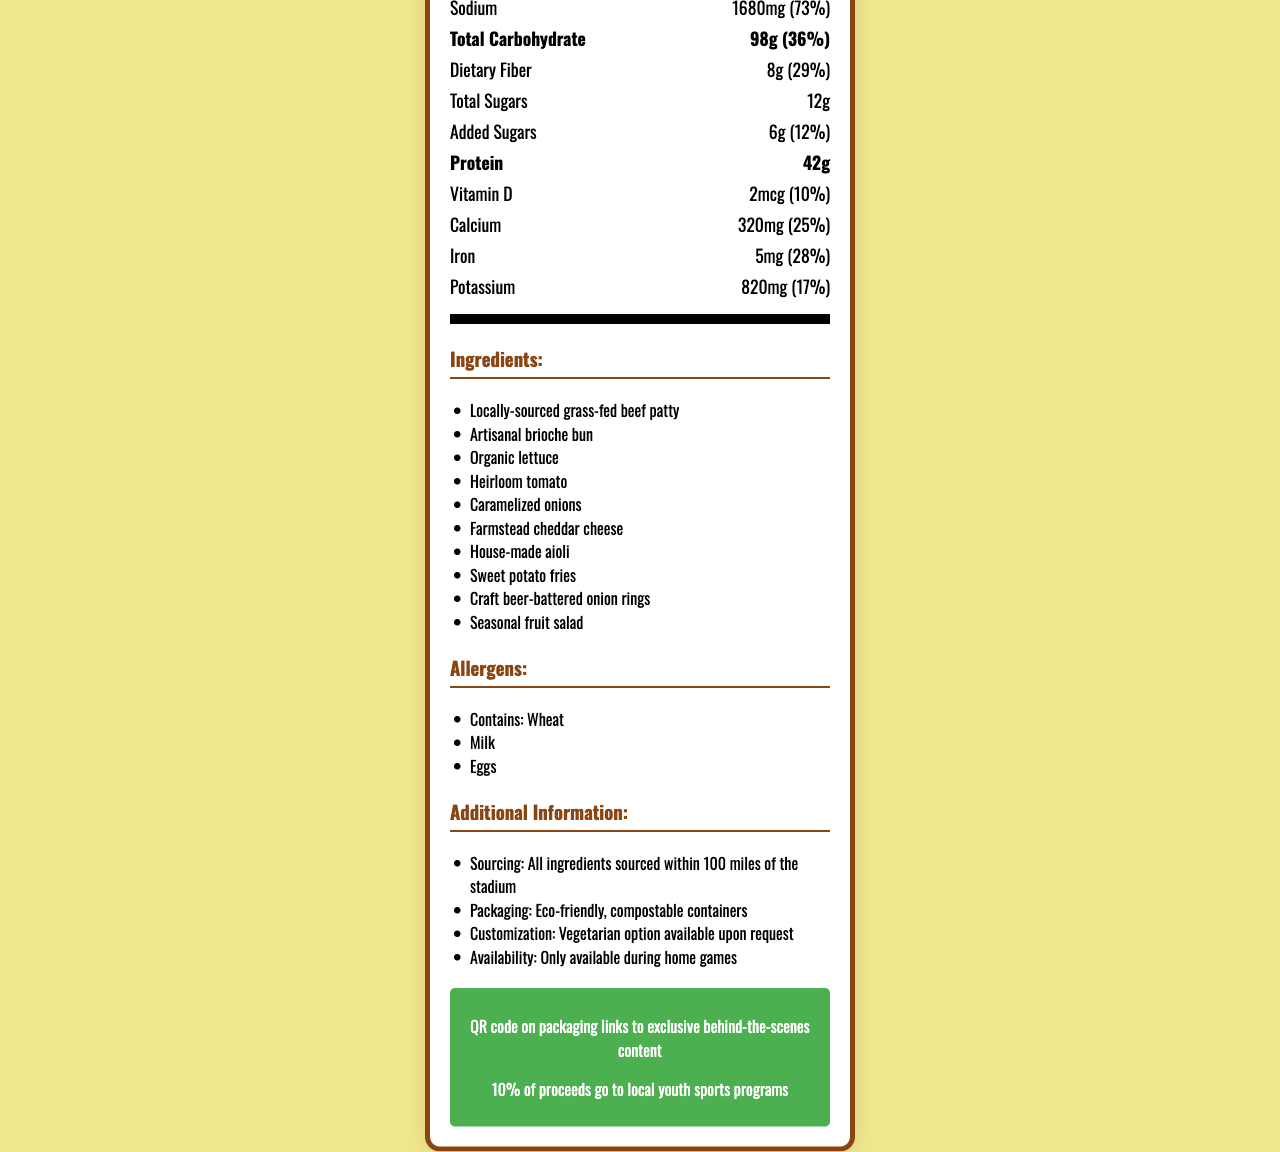what is the serving size for the Touchdown Tailgate Meal Kit? The serving size listed in the document is "1 kit (680g)".
Answer: 1 kit (680g) How many calories does one serving of this meal kit contain? The document specifies that one serving contains 950 calories.
Answer: 950 What is the daily value percentage of sodium in this meal kit? The nutrition facts indicate that the sodium content contributes to 73% of the daily value.
Answer: 73% Name three ingredients included in the Touchdown Tailgate Meal Kit. These ingredients are listed in the ingredients section of the document.
Answer: Locally-sourced grass-fed beef patty, Artisanal brioche bun, Organic lettuce Does this meal kit contain any trans fat? The document specifies that the amount of trans fat is 0g.
Answer: No What is the percentage daily value of saturated fat in the meal kit? The document lists the percentage daily value of saturated fat as 60%.
Answer: 60% What are the allergens mentioned on the nutrition facts label? The allergens section lists these three allergens explicitly.
Answer: Wheat, Milk, Eggs What percentage of the proceeds goes to local youth sports programs? A. 5% B. 10% C. 15% D. 20% The fan engagement section of the document states that 10% of the proceeds go to local youth sports programs.
Answer: B What is the protein content per serving in this meal kit? The nutrition facts state that each serving contains 42g of protein.
Answer: 42g What is the daily value percentage of dietary fiber in this meal kit? The document indicates that the dietary fiber in the meal kit constitutes 29% of the daily value.
Answer: 29% Which of these is an option for customizing the meal kit? I. Gluten-free II. Low-carb III. Vegetarian IV. Vegan The additional information section notes that a vegetarian option is available upon request, but there is no mention of gluten-free, low-carb, or vegan options.
Answer: III Is there a QR code for exclusive behind-the-scenes content on the packaging? The fan engagement section of the document states that there is a QR code on the packaging for exclusive behind-the-scenes content.
Answer: Yes Describe the main features and elements of the Touchdown Tailgate Meal Kit nutrition document. The document offers a comprehensive overview of the meal kit’s nutritional content and additional features, showcasing locally sourced ingredients, eco-friendly packaging, customization options, and fan engagement initiatives.
Answer: The document displays the nutrition facts for the Touchdown Tailgate Meal Kit, detailing a single-serving meal's serving size, calories, and various nutritional components like fat, cholesterol, sodium, carbohydrates, proteins, and vitamins. It includes ingredients sourced locally within 100 miles of the stadium, allergen information, and additional details on sourcing, packaging, customization, and fan engagement. A unique feature is a QR code linking to exclusive content, and 10% of proceeds support local youth sports programs. What is the exact weight in grams of the added sugars per serving? The document specifies that the added sugars amount to 6g per serving.
Answer: 6g Can someone with a milk allergy safely consume this meal kit? The allergens section indicates that the meal kit contains milk.
Answer: No Which of these minerals has the highest daily value percentage in this meal kit? A. Vitamin D B. Calcium C. Iron D. Potassium Calcium has a daily value percentage of 25%, which is higher than the percentages for vitamin D (10%), iron (28%), and potassium (17%).
Answer: B What is the source of the cheddar cheese in the meal kit? The document indicates "Farmstead cheddar cheese" but does not specify the exact source beyond mentioning it is locally sourced.
Answer: Cannot be determined 